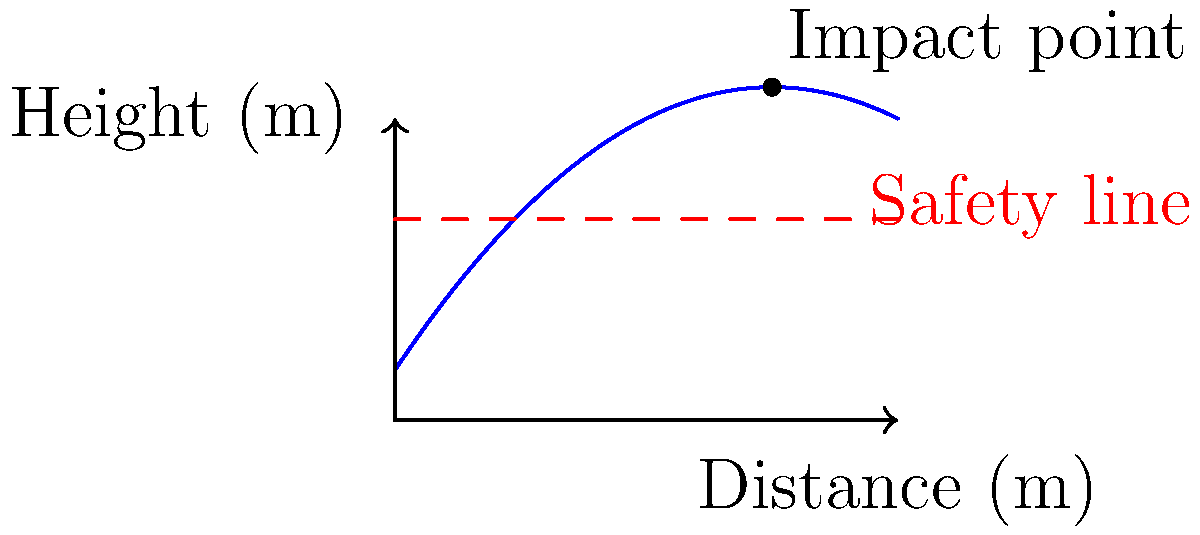A construction worker is using a catapult to launch debris over a safety barrier. The trajectory of the debris can be modeled by the function $h(x) = -0.05x^2 + 1.5x + 2$, where $h$ is the height in meters and $x$ is the horizontal distance in meters. The safety barrier is 8 meters high. At what horizontal distance does the debris impact the ground, and does it clear the safety barrier? To solve this problem, we need to follow these steps:

1) To find where the debris impacts the ground, we need to find where $h(x) = 0$:

   $0 = -0.05x^2 + 1.5x + 2$

2) This is a quadratic equation. We can solve it using the quadratic formula:
   $x = \frac{-b \pm \sqrt{b^2 - 4ac}}{2a}$

   Where $a = -0.05$, $b = 1.5$, and $c = 2$

3) Plugging these values into the quadratic formula:

   $x = \frac{-1.5 \pm \sqrt{1.5^2 - 4(-0.05)(2)}}{2(-0.05)}$

4) Simplifying:

   $x = \frac{-1.5 \pm \sqrt{2.25 + 0.4}}{-0.1} = \frac{-1.5 \pm \sqrt{2.65}}{-0.1}$

5) This gives us two solutions: $x \approx -1.63$ or $x \approx 30.63$

6) Since negative distance doesn't make sense in this context, the debris impacts the ground at approximately 30.63 meters.

7) To check if it clears the safety barrier, we need to find the maximum height of the trajectory:

   The vertex of a parabola occurs at $x = -\frac{b}{2a} = -\frac{1.5}{2(-0.05)} = 15$ meters

8) The height at this point is:

   $h(15) = -0.05(15)^2 + 1.5(15) + 2 = 13.25$ meters

9) Since 13.25 meters is greater than the 8-meter height of the safety barrier, the debris clears the barrier.
Answer: Impact at 30.63 m; clears barrier 